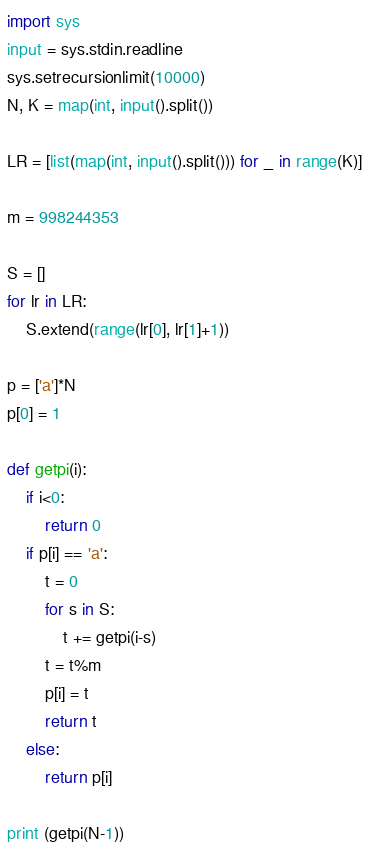<code> <loc_0><loc_0><loc_500><loc_500><_Python_>
import sys
input = sys.stdin.readline
sys.setrecursionlimit(10000)
N, K = map(int, input().split())

LR = [list(map(int, input().split())) for _ in range(K)]

m = 998244353

S = []
for lr in LR:
    S.extend(range(lr[0], lr[1]+1))

p = ['a']*N
p[0] = 1

def getpi(i):
    if i<0:
        return 0
    if p[i] == 'a':
        t = 0
        for s in S:
            t += getpi(i-s)
        t = t%m
        p[i] = t
        return t 
    else:
        return p[i]

print (getpi(N-1))</code> 